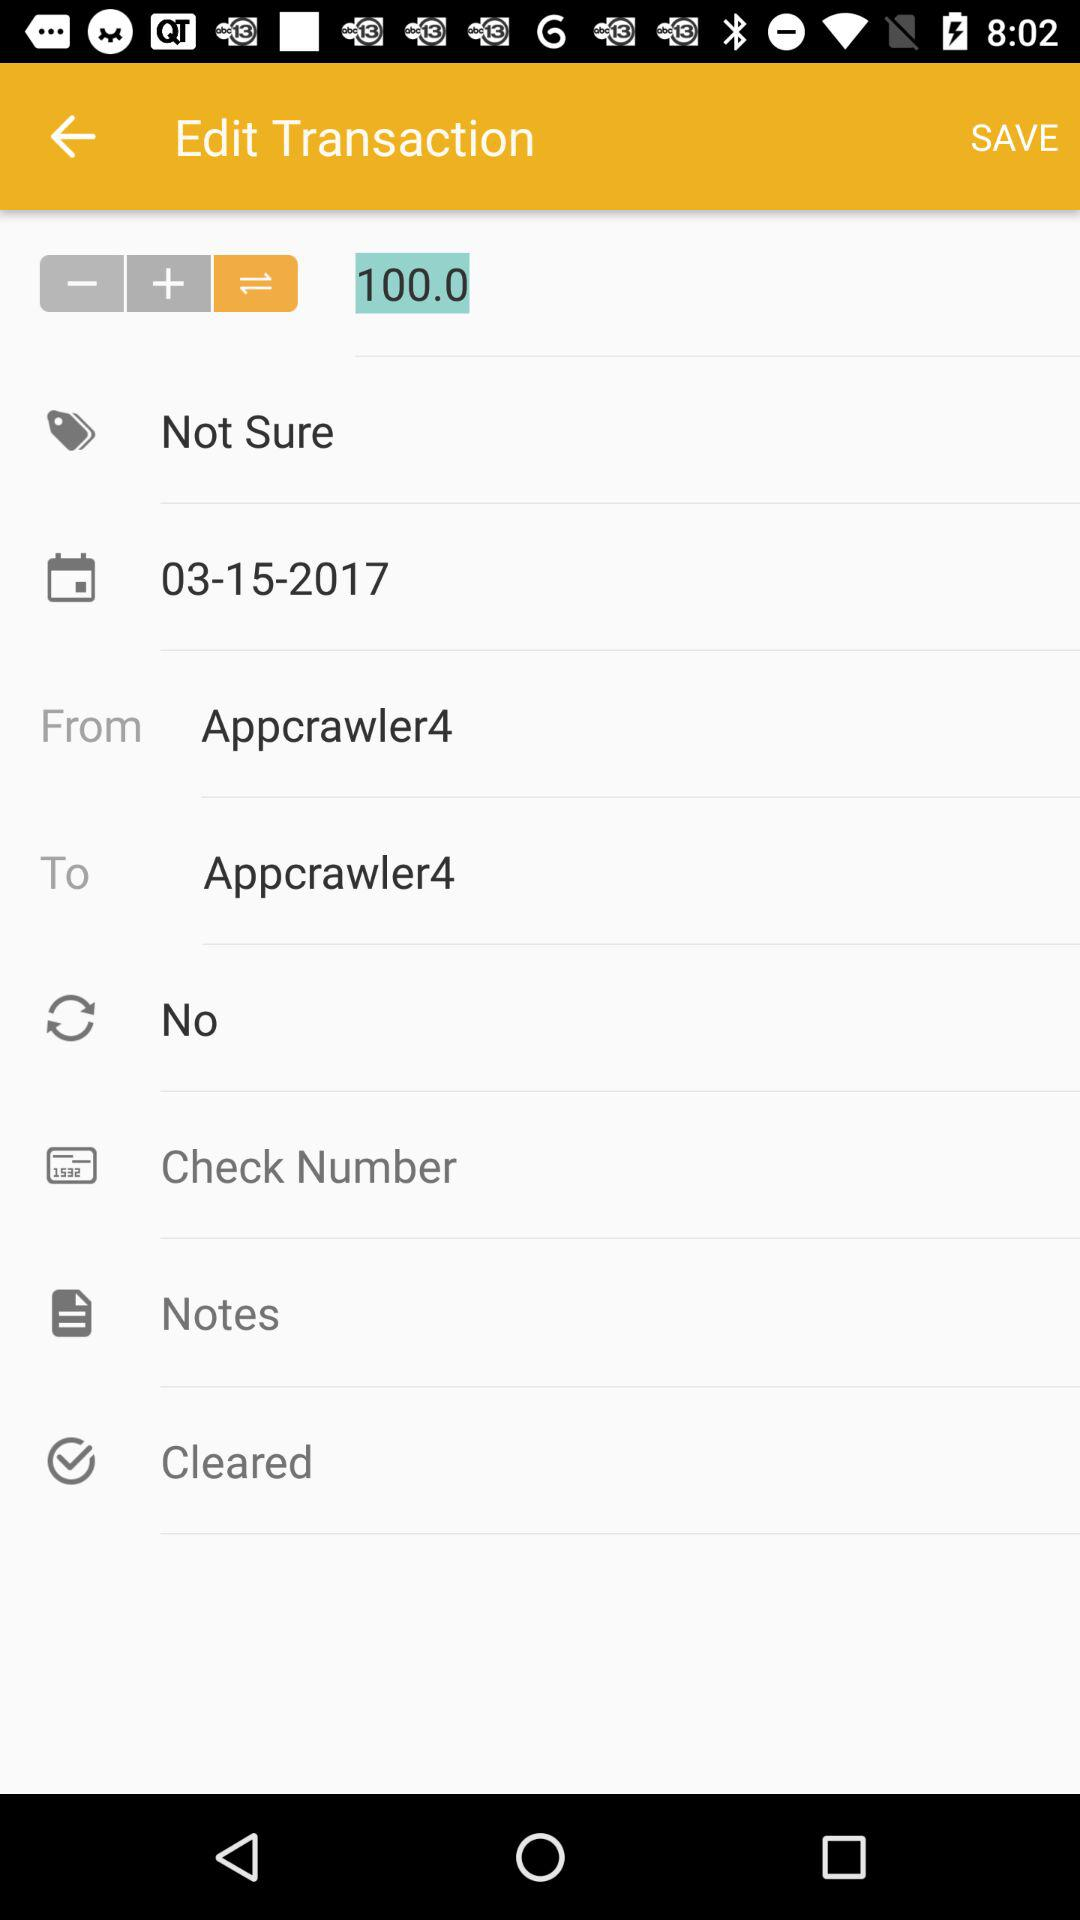Who is the receiver? The receiver is "Appcrawler4". 